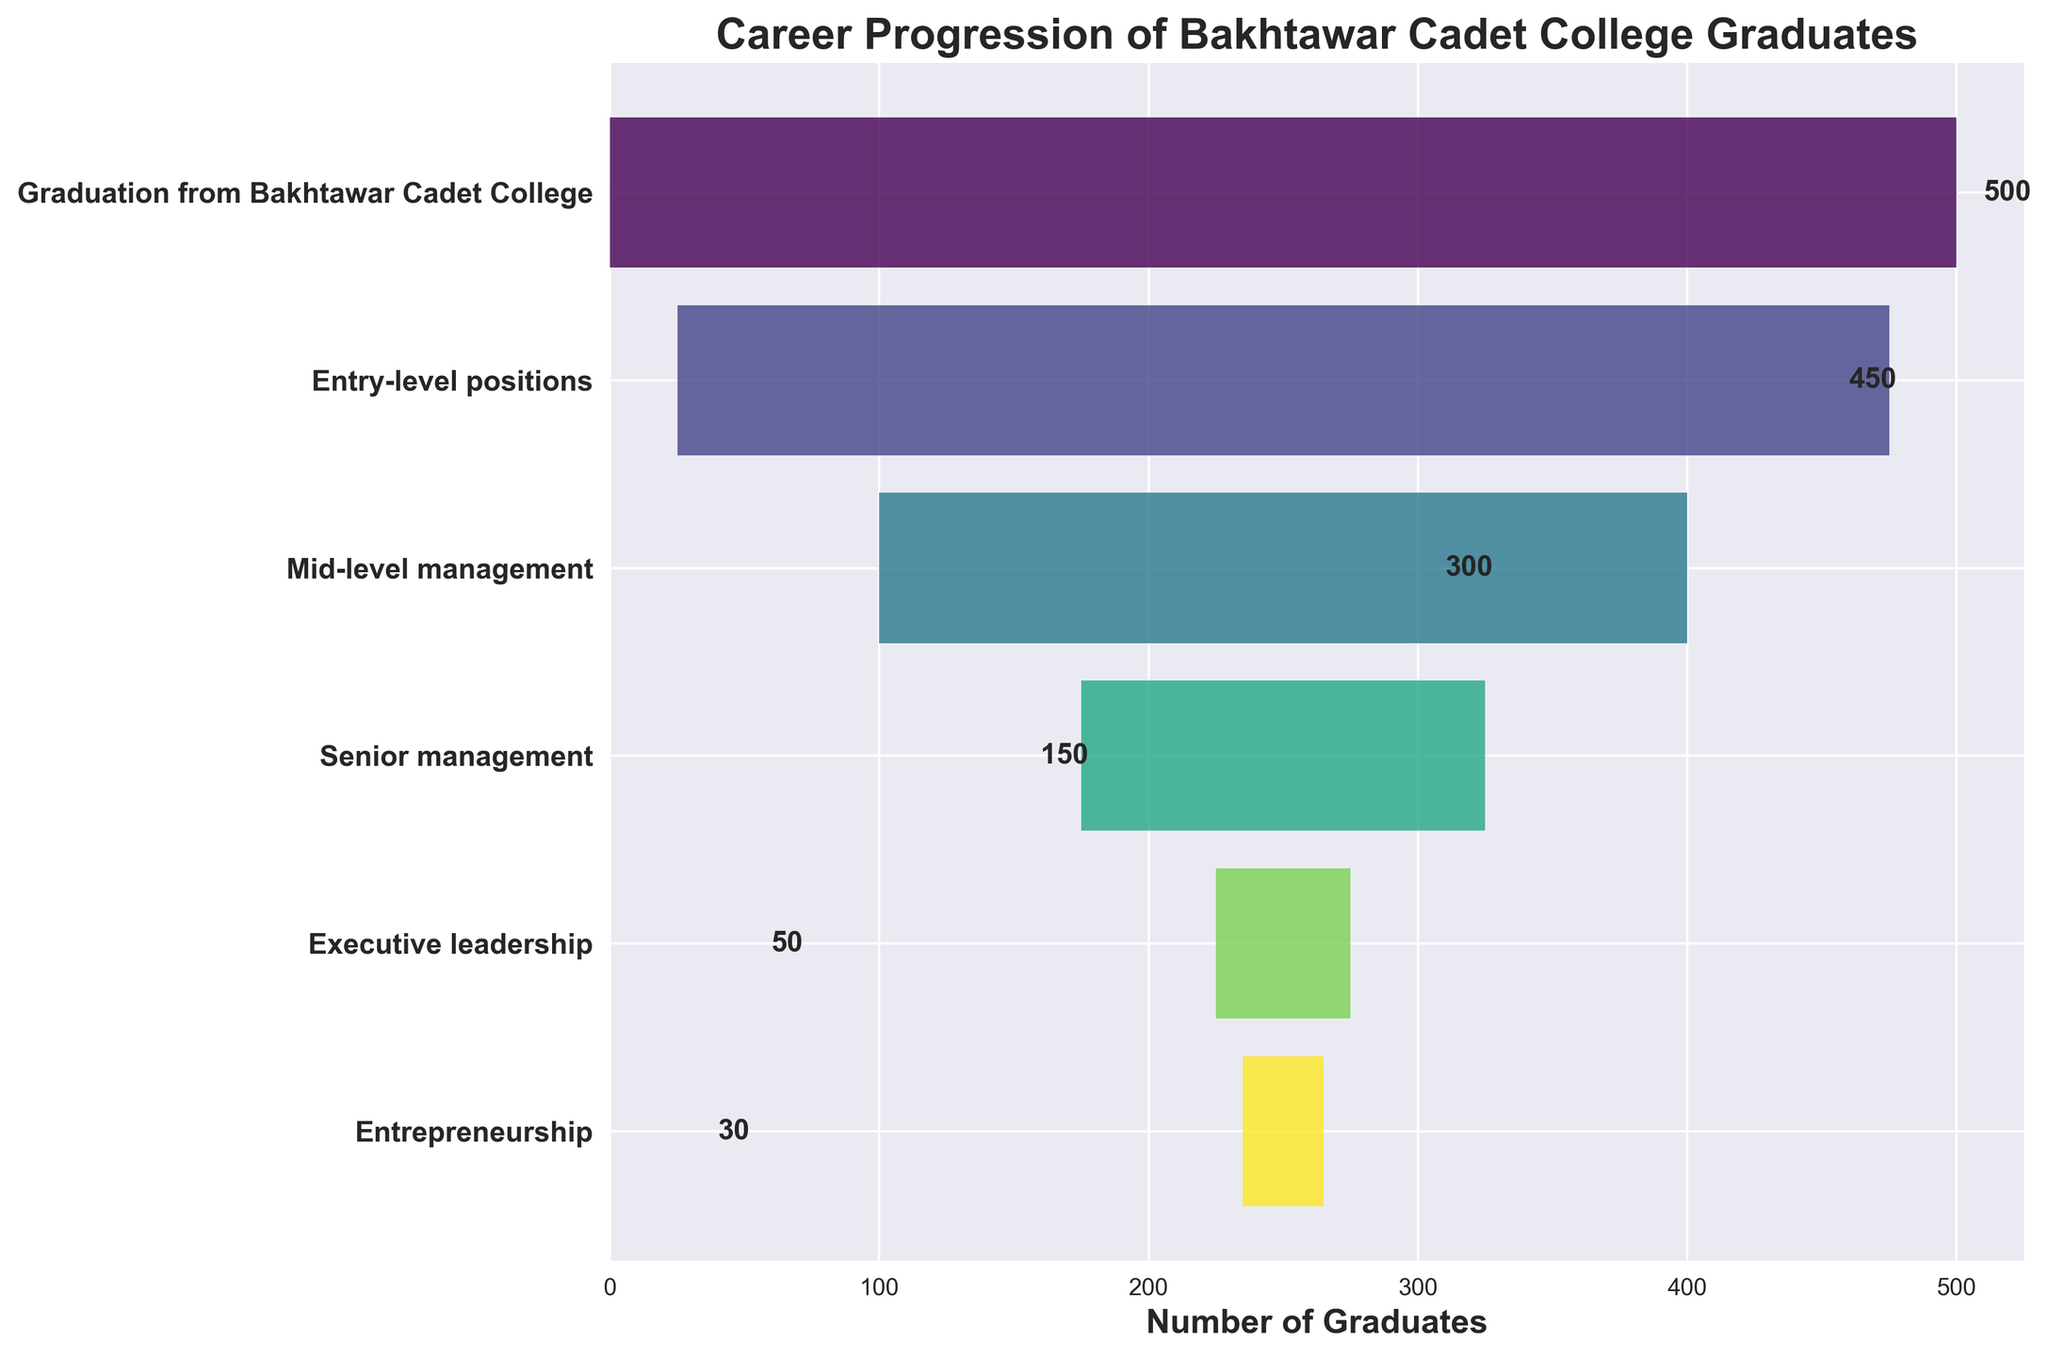What is the title of the funnel chart? The title is located at the top of the funnel chart in bold. It indicates what the chart represents.
Answer: Career Progression of Bakhtawar Cadet College Graduates How many stages are shown in the funnel chart? Each stage represents a different level in the career progression and is marked by a horizontal bar. Count the total number of horizontal bars from top to bottom.
Answer: 6 At which stage does the number of graduates drop below 100? Look at the numbers labeled on the horizontal bars. Identify the first stage where the label value is less than 100.
Answer: Executive leadership How many graduates are in Senior management and Executive leadership combined? Identify the numbers for Senior management and Executive leadership and add them together. Senior management has 150 graduates and Executive leadership has 50 graduates. 150 + 50 = 200.
Answer: 200 How many more graduates are in Entry-level positions compared to Entrepreneurship? Find the number of graduates in Entry-level positions and Entrepreneurship. Subtract the number of Entrepreneurship graduates from the number of Entry-level graduates. Entry-level positions have 450 graduates and Entrepreneurship has 30 graduates. 450 - 30 = 420.
Answer: 420 Which stage has the highest number of graduates and how many are there? Identify the stage with the widest bar, indicating the largest number of graduates. The corresponding label on the bar will give the exact number.
Answer: Graduation from Bakhtawar Cadet College, 500 What is the percentage reduction in graduates from Mid-level management to Senior management? First, find the number of graduates at both stages. Then calculate the difference and divide by the number of graduates at Mid-level management, and multiply by 100 to get the percentage. (300 - 150) / 300 * 100 = 50%.
Answer: 50% Excluding the graduation stage, what is the average number of graduates across all other stages? Sum all the numbers from Entry-level positions to Entrepreneurship and divide by the count of those stages, which is 5. (450 + 300 + 150 + 50 + 30) / 5 = 980 / 5 = 196.
Answer: 196 Which stage has the most significant drop in the number of graduates? Find the stage with the largest decrease in the number compared to the previous stage. Calculate the differences like this: 500-450 = 50, 450-300 = 150, 300-150 = 150, 150-50 = 100, 50-30 = 20. The most significant drop is from 450 to 300 or from Entry-level positions to Mid-level management.
Answer: Entry-level positions to Mid-level management 